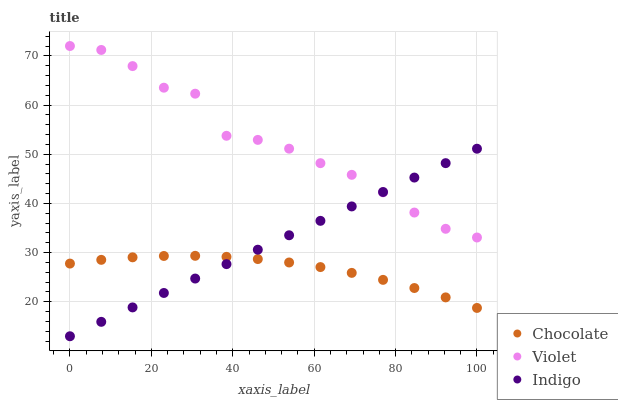Does Chocolate have the minimum area under the curve?
Answer yes or no. Yes. Does Violet have the maximum area under the curve?
Answer yes or no. Yes. Does Indigo have the minimum area under the curve?
Answer yes or no. No. Does Indigo have the maximum area under the curve?
Answer yes or no. No. Is Indigo the smoothest?
Answer yes or no. Yes. Is Violet the roughest?
Answer yes or no. Yes. Is Chocolate the smoothest?
Answer yes or no. No. Is Chocolate the roughest?
Answer yes or no. No. Does Indigo have the lowest value?
Answer yes or no. Yes. Does Chocolate have the lowest value?
Answer yes or no. No. Does Violet have the highest value?
Answer yes or no. Yes. Does Indigo have the highest value?
Answer yes or no. No. Is Chocolate less than Violet?
Answer yes or no. Yes. Is Violet greater than Chocolate?
Answer yes or no. Yes. Does Indigo intersect Violet?
Answer yes or no. Yes. Is Indigo less than Violet?
Answer yes or no. No. Is Indigo greater than Violet?
Answer yes or no. No. Does Chocolate intersect Violet?
Answer yes or no. No. 